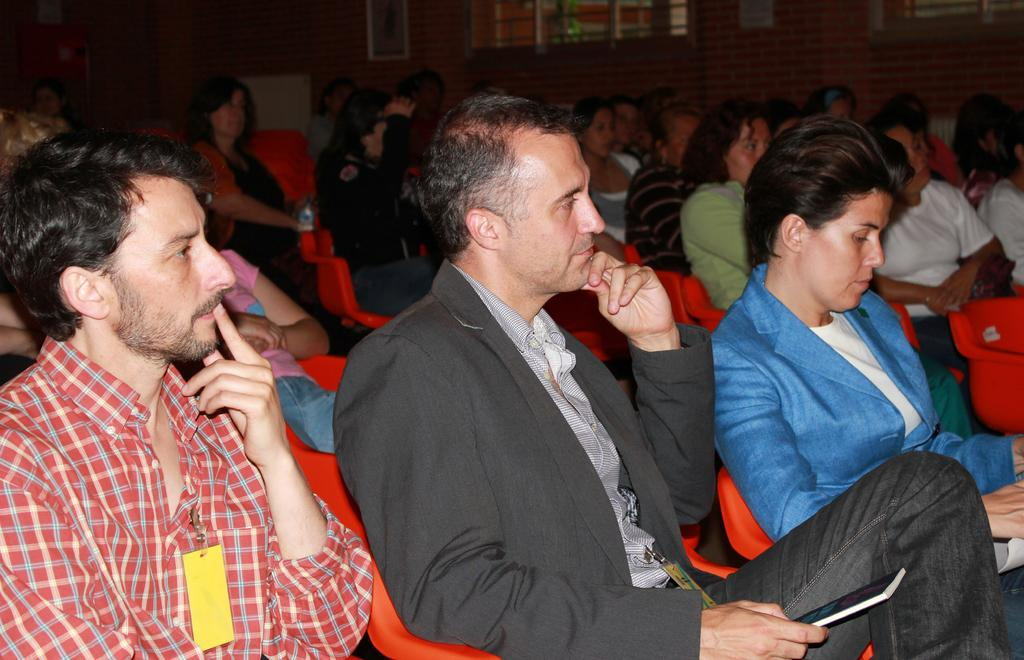What type of setting is depicted in the image? The image is an inside view. What are the people in the image doing? There are many people sitting on chairs in the image. Which direction are the people facing? The people are facing towards the right side. What can be seen in the background of the image? There is a wall and windows in the background. What type of stone is being used to teach the class in the image? There is no class or stone present in the image; it depicts people sitting on chairs facing towards the right side. 